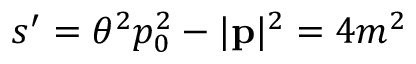<formula> <loc_0><loc_0><loc_500><loc_500>s ^ { \prime } = \theta ^ { 2 } p _ { 0 } ^ { 2 } - | p | ^ { 2 } = 4 m ^ { 2 }</formula> 